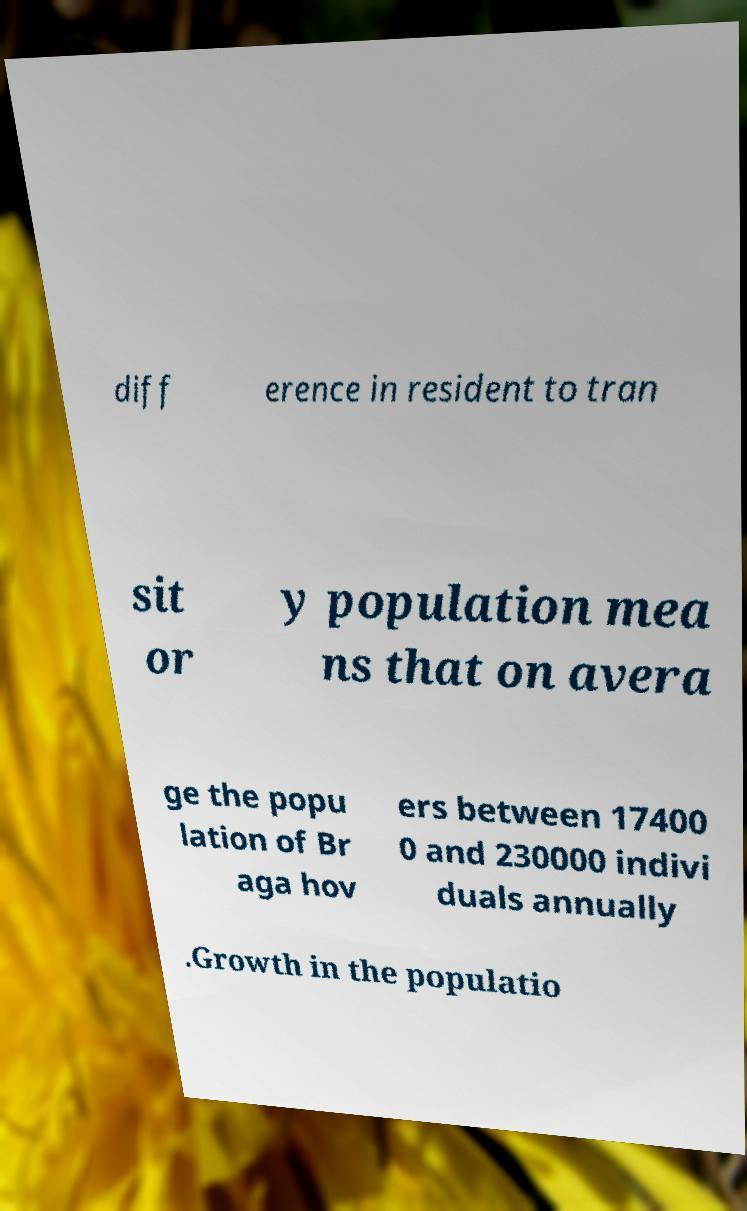Please identify and transcribe the text found in this image. diff erence in resident to tran sit or y population mea ns that on avera ge the popu lation of Br aga hov ers between 17400 0 and 230000 indivi duals annually .Growth in the populatio 